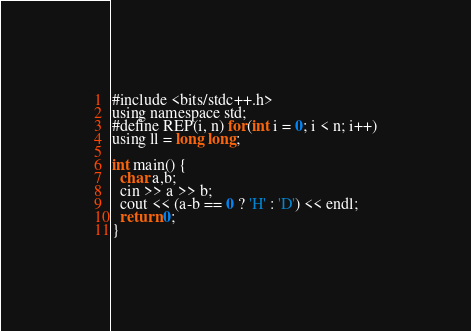<code> <loc_0><loc_0><loc_500><loc_500><_JavaScript_>#include <bits/stdc++.h>
using namespace std;
#define REP(i, n) for(int i = 0; i < n; i++)
using ll = long long;

int main() {
  char a,b;
  cin >> a >> b;
  cout << (a-b == 0 ? 'H' : 'D') << endl;
  return 0;
}</code> 